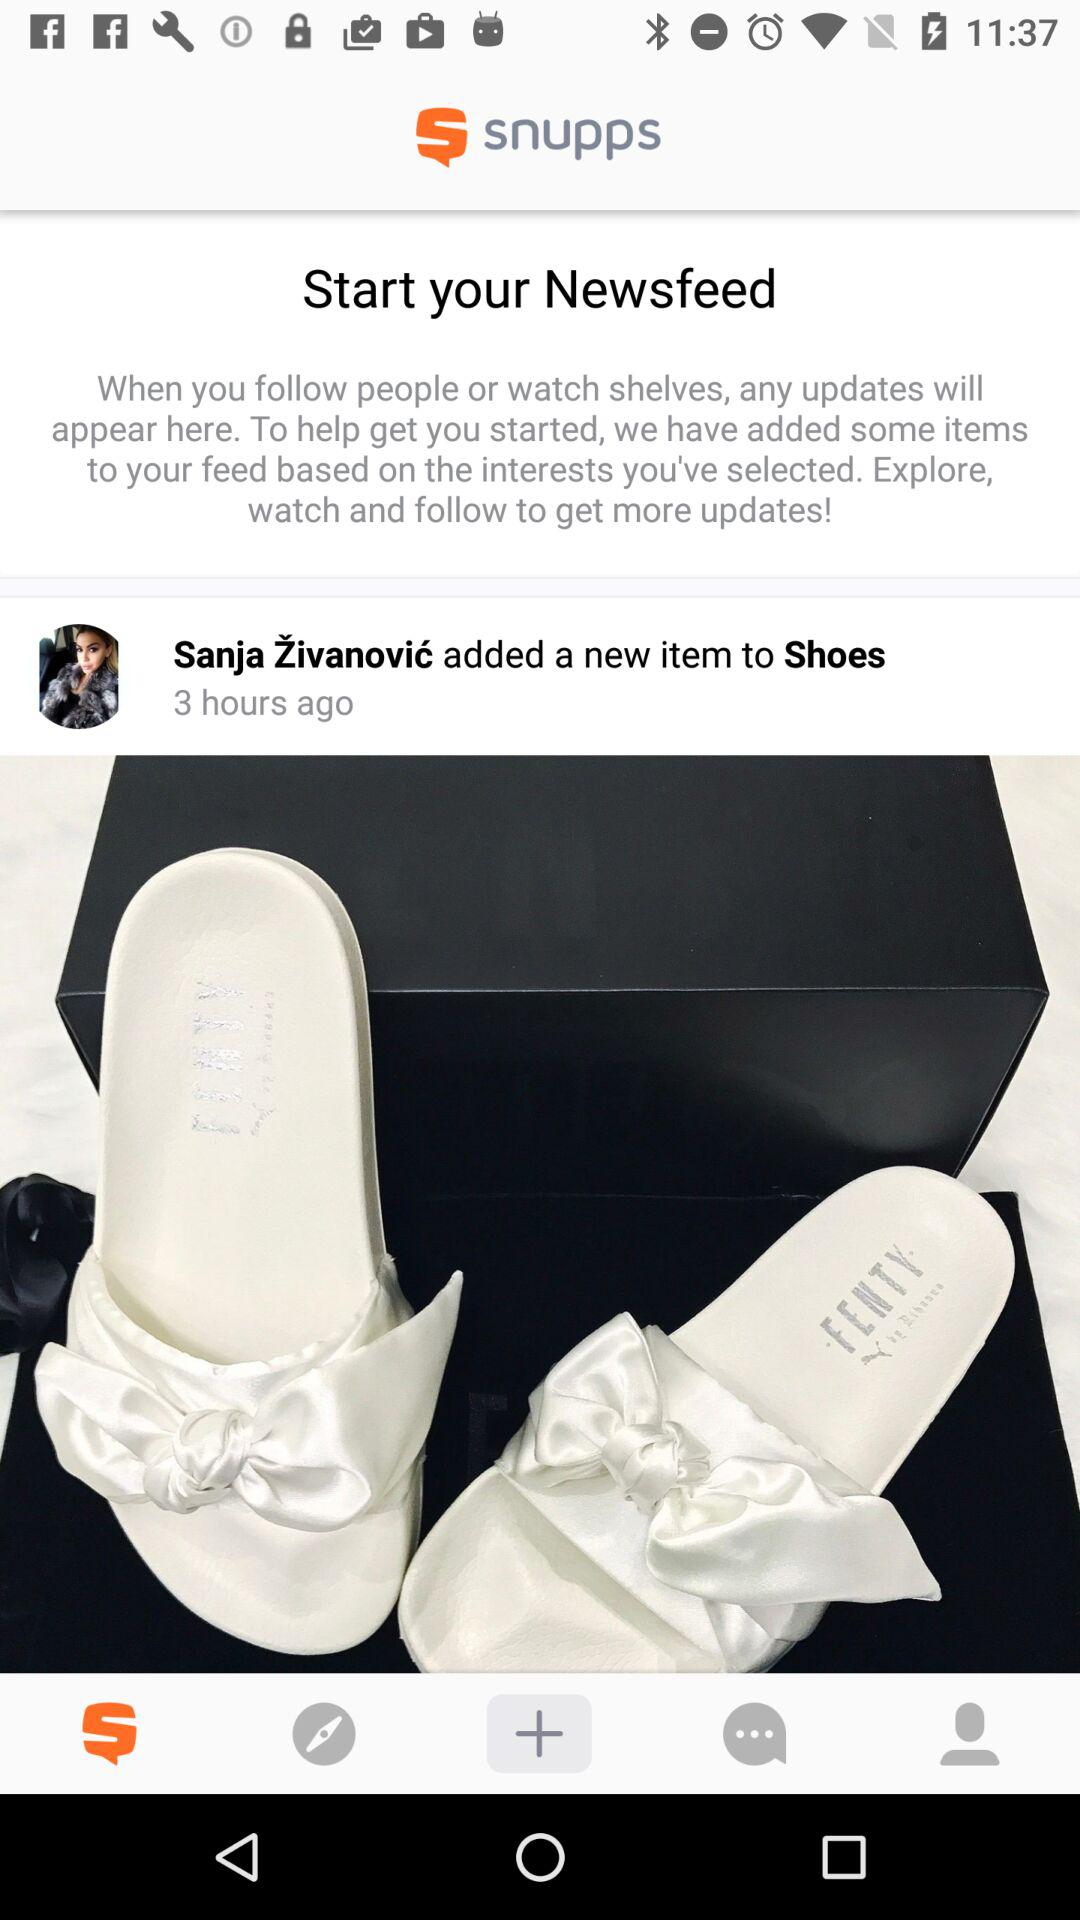How many hours ago did Sanja Živanović add a new item to Shoes?
Answer the question using a single word or phrase. 3 hours ago 